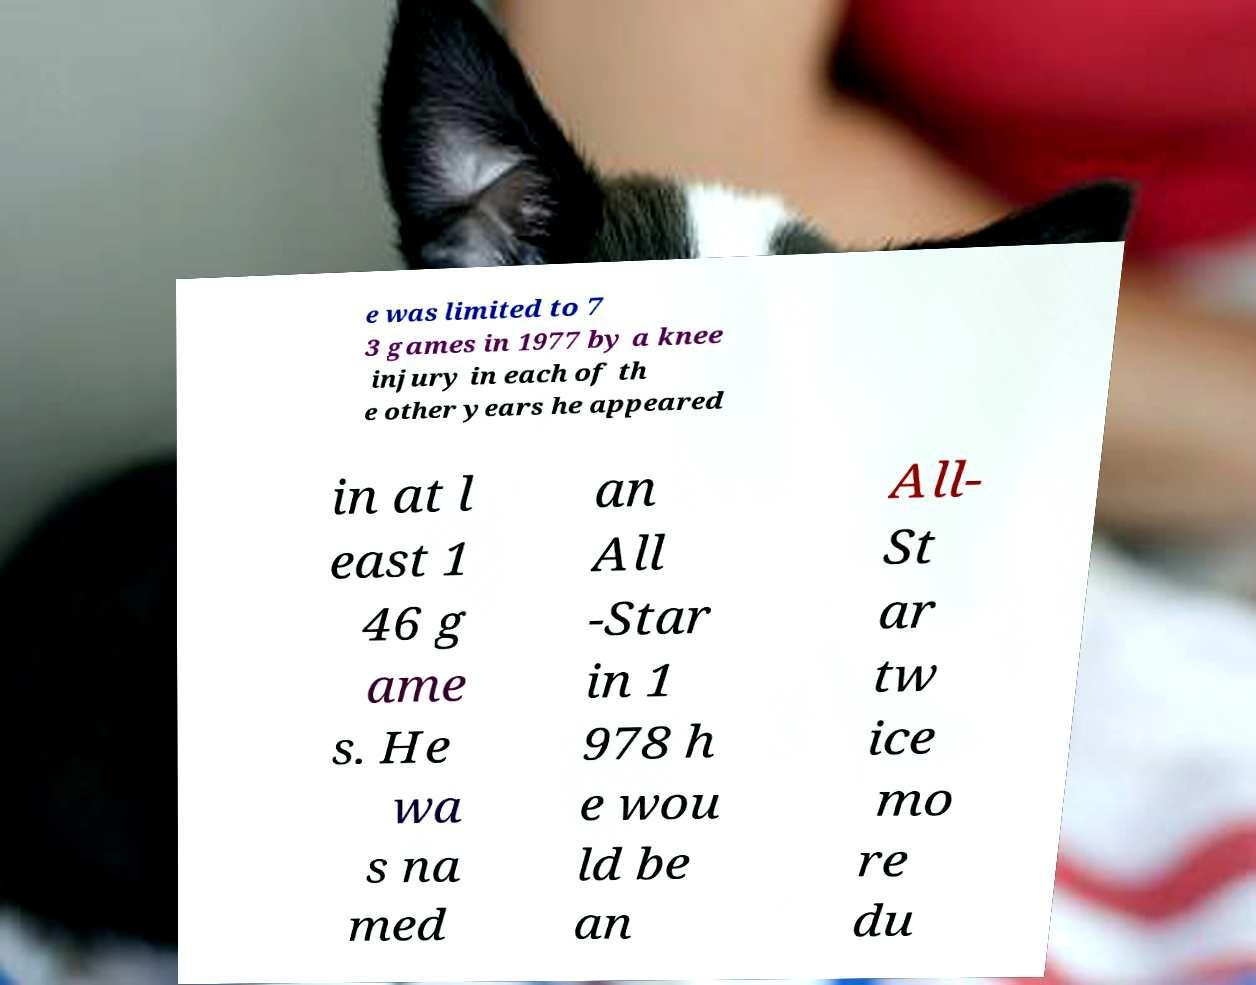I need the written content from this picture converted into text. Can you do that? e was limited to 7 3 games in 1977 by a knee injury in each of th e other years he appeared in at l east 1 46 g ame s. He wa s na med an All -Star in 1 978 h e wou ld be an All- St ar tw ice mo re du 